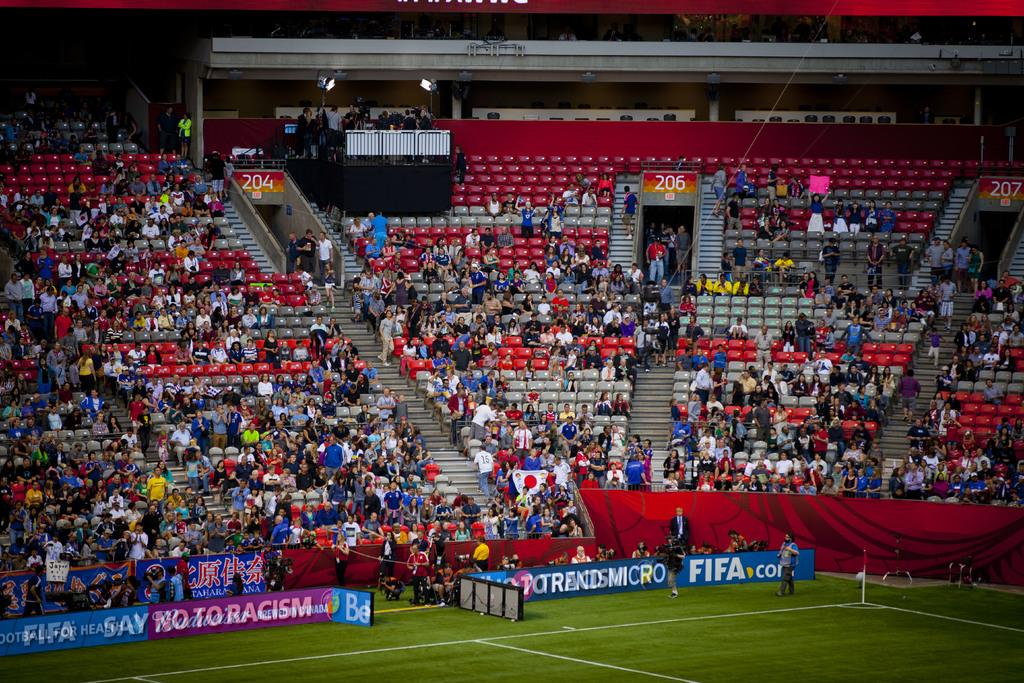What type of structure is visible in the image? There is a stadium in the image. What are the people in the image doing? There are groups of people sitting on chairs and standing in the image. What objects can be seen in the image that are used for displaying information or advertisements? There are boards and banners in the image. What architectural feature is present in the image that allows people to move between different levels? There are stairs in the image. What type of lighting is present in the image? There are lights in the image. What type of calendar is hanging on the wall in the image? There is no calendar present in the image. Can you tell me how many zippers are visible on the people's clothing in the image? There is no mention of zippers or clothing in the provided facts, so it cannot be determined from the image. What type of cup is being used by the people in the image? There is no cup visible in the image. 